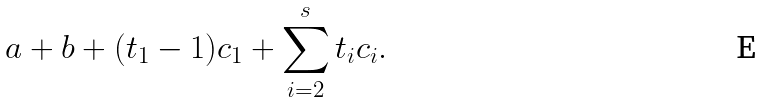<formula> <loc_0><loc_0><loc_500><loc_500>a + b + ( t _ { 1 } - 1 ) c _ { 1 } + \sum _ { i = 2 } ^ { s } t _ { i } c _ { i } .</formula> 